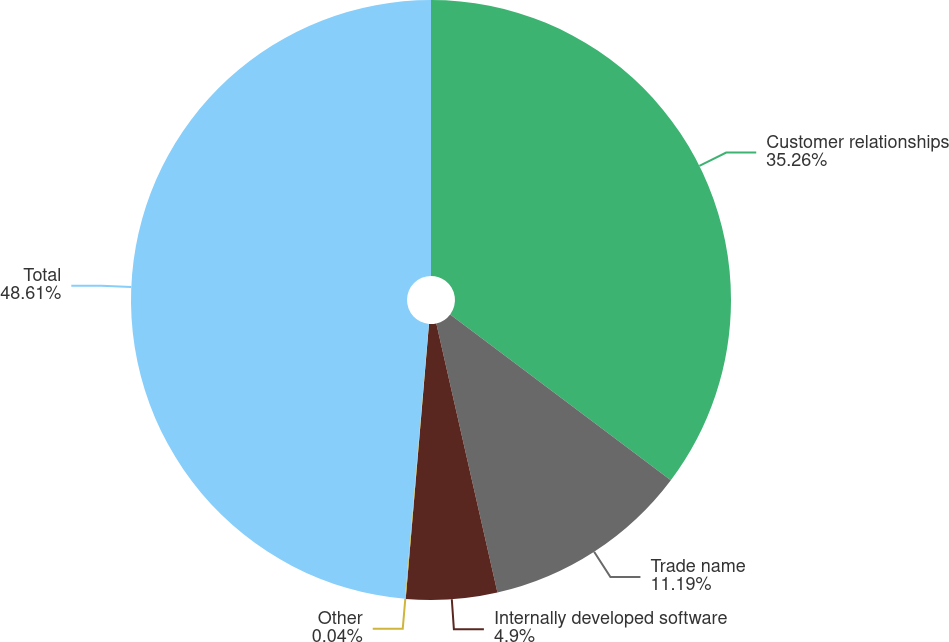Convert chart. <chart><loc_0><loc_0><loc_500><loc_500><pie_chart><fcel>Customer relationships<fcel>Trade name<fcel>Internally developed software<fcel>Other<fcel>Total<nl><fcel>35.26%<fcel>11.19%<fcel>4.9%<fcel>0.04%<fcel>48.62%<nl></chart> 